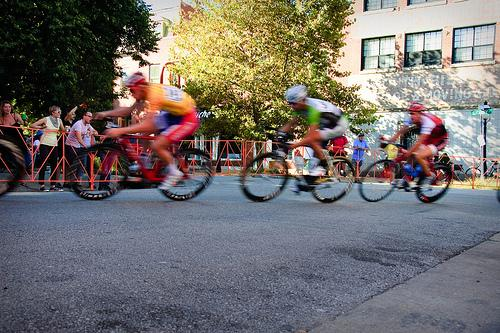In the context of a bicycle safety campaign, what message does this image convey? Wear bright clothing while cycling, and always be alert and aware of other cyclists and road users to ensure everyone's safety. Select one object in the image and provide a brief description. There is a tree with green leaves located on the city street. If you were to create a commercial advertisement for bicycles based on this image, what would be the slogan? "Race to the Finish Line - Speed and Style Redefined with Our Bikes!" Provide a short, poetic description of the image. Wheels in motion, colors in harmony, cyclists speeding down the street, embracing the race of life. What would be a reason for someone to share this image with others, perhaps on social media? To highlight the excitement of watching a bicycle race in person or to show support for the race participants. Identify the primary activity taking place in the image and the number of participants involved. The primary activity is a bicycle race with multiple bicyclists participating. Please provide a short, catchy caption for the image for use in a magazine article. "Pedal to the Metal: An Insight into the Thrilling World of Bicycle Races!" Are there any people on bicycles in the image? If so, what are they doing? Yes, there are several people on bicycles, they are racing along a roadway. Identify a striking detail or feature in the image that could catch the viewer's attention. The vibrant colors of the cyclists' shirts and the sense of motion and adrenaline in the race. If this image represents a moment in a story, what descriptive sentence would follow it? With determination and fierce competition, the cyclists pedaled even harder toward the finish line, their eyes locked on the prize. 